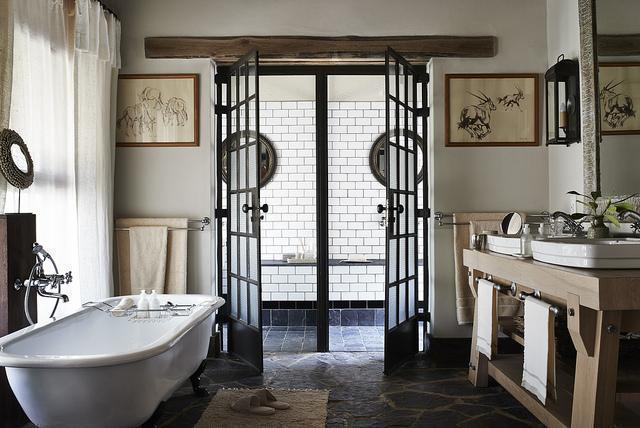The floor of the bathroom is made of what material?
Pick the right solution, then justify: 'Answer: answer
Rationale: rationale.'
Options: Carpet, wood, vinyl, stone. Answer: stone.
Rationale: The floor appears to be covered in flat, irregular sized hard rocks that are pieced together with grout. 